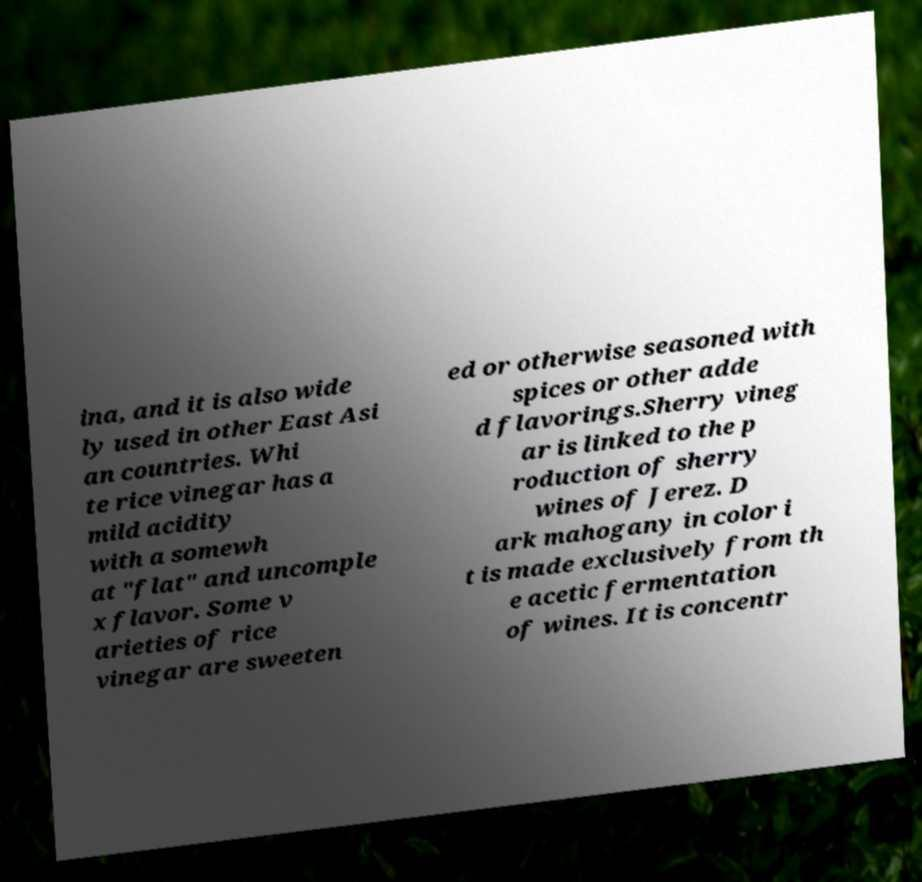I need the written content from this picture converted into text. Can you do that? ina, and it is also wide ly used in other East Asi an countries. Whi te rice vinegar has a mild acidity with a somewh at "flat" and uncomple x flavor. Some v arieties of rice vinegar are sweeten ed or otherwise seasoned with spices or other adde d flavorings.Sherry vineg ar is linked to the p roduction of sherry wines of Jerez. D ark mahogany in color i t is made exclusively from th e acetic fermentation of wines. It is concentr 